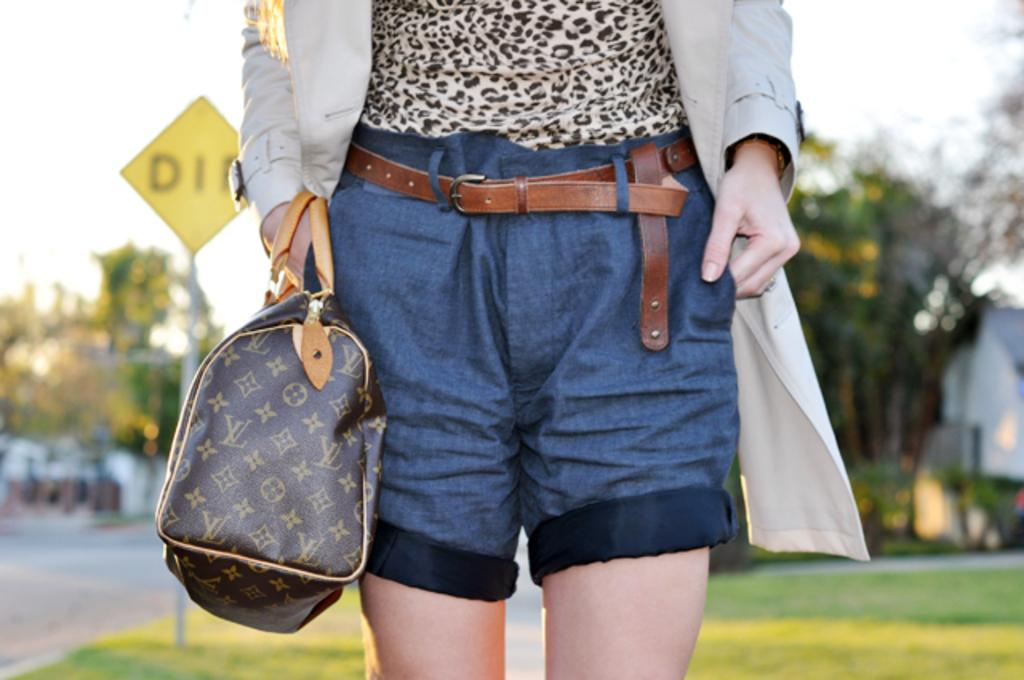Who is the main subject in the image? There is a girl in the image. What is the girl wearing? The girl is wearing trousers, a jacket, and a belt. What is the girl holding in the image? The girl is holding a bag. What can be seen in the background of the image? There is a green grass lawn, trees, and a sign board in the background of the image. What type of coal is being mined in the background of the image? There is no coal or mining activity present in the image. What idea does the sign board in the background of the image represent? The sign board in the background of the image does not convey any specific idea; it is simply a part of the background. 